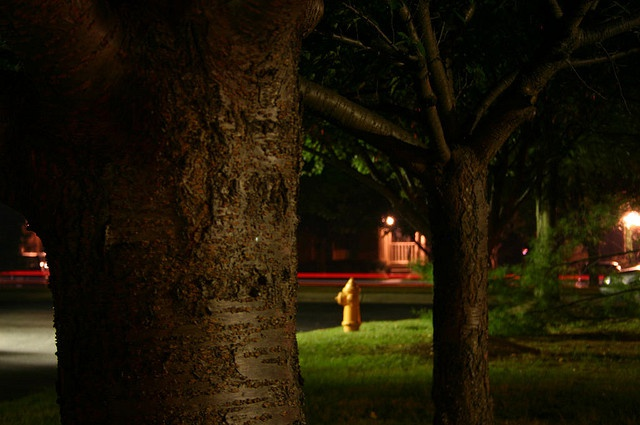Describe the objects in this image and their specific colors. I can see fire hydrant in black, maroon, olive, gold, and orange tones, car in black, maroon, and brown tones, and car in black, darkgreen, gray, and tan tones in this image. 